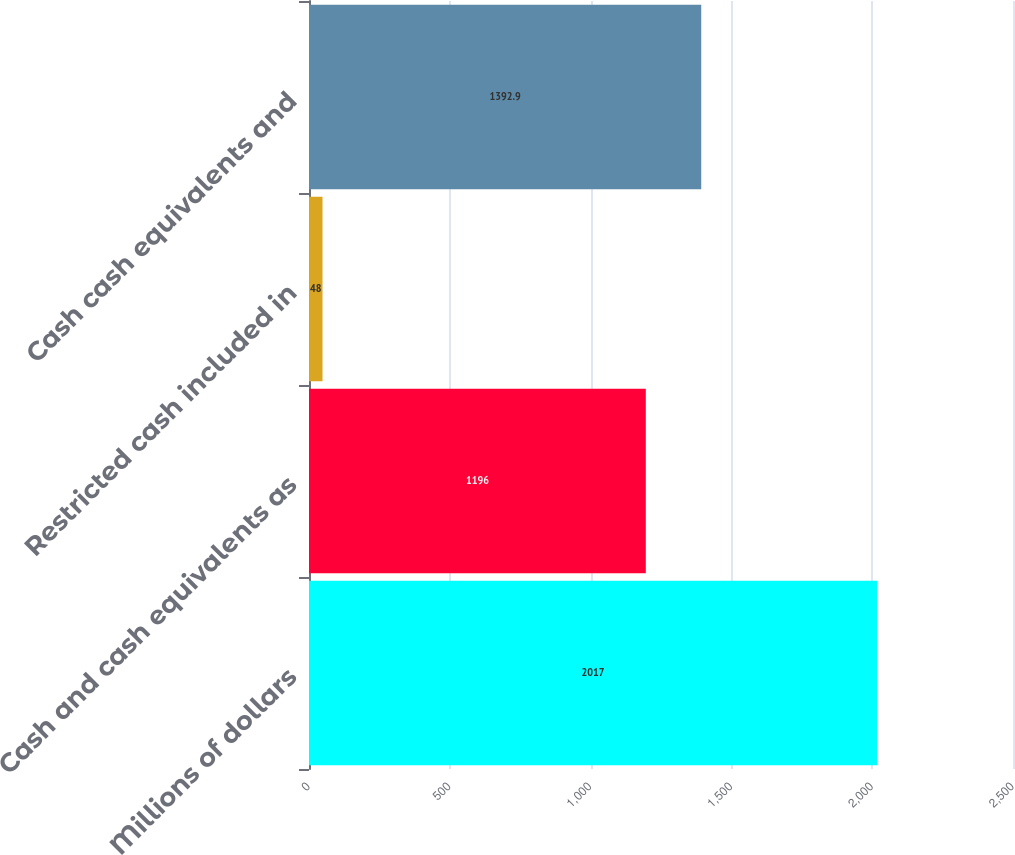<chart> <loc_0><loc_0><loc_500><loc_500><bar_chart><fcel>Millions of dollars<fcel>Cash and cash equivalents as<fcel>Restricted cash included in<fcel>Cash cash equivalents and<nl><fcel>2017<fcel>1196<fcel>48<fcel>1392.9<nl></chart> 